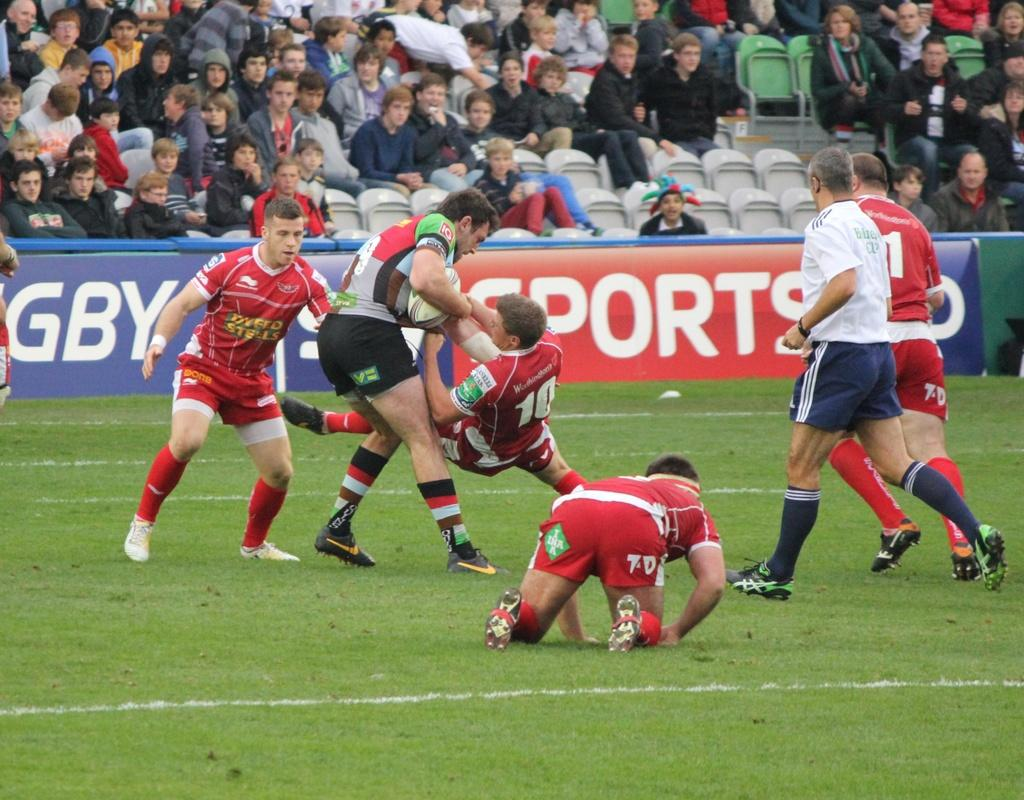<image>
Relay a brief, clear account of the picture shown. A rugby game goes on in front of a sign that reads Sports. 